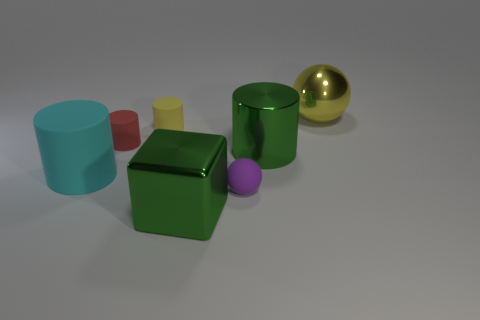The small red object has what shape?
Give a very brief answer. Cylinder. How many things are spheres in front of the yellow rubber object or big green shiny objects?
Keep it short and to the point. 3. How many other things are there of the same color as the metallic block?
Your response must be concise. 1. There is a big shiny cylinder; does it have the same color as the metallic thing in front of the big cyan cylinder?
Provide a short and direct response. Yes. There is another tiny matte object that is the same shape as the small yellow matte thing; what color is it?
Ensure brevity in your answer.  Red. Does the green block have the same material as the big yellow object that is to the right of the green cylinder?
Your response must be concise. Yes. The big rubber object has what color?
Provide a succinct answer. Cyan. There is a ball that is to the right of the cylinder that is to the right of the yellow thing to the left of the large ball; what is its color?
Offer a very short reply. Yellow. Do the large cyan thing and the small purple matte thing left of the green metal cylinder have the same shape?
Make the answer very short. No. What color is the object that is right of the yellow cylinder and behind the tiny red object?
Provide a succinct answer. Yellow. 